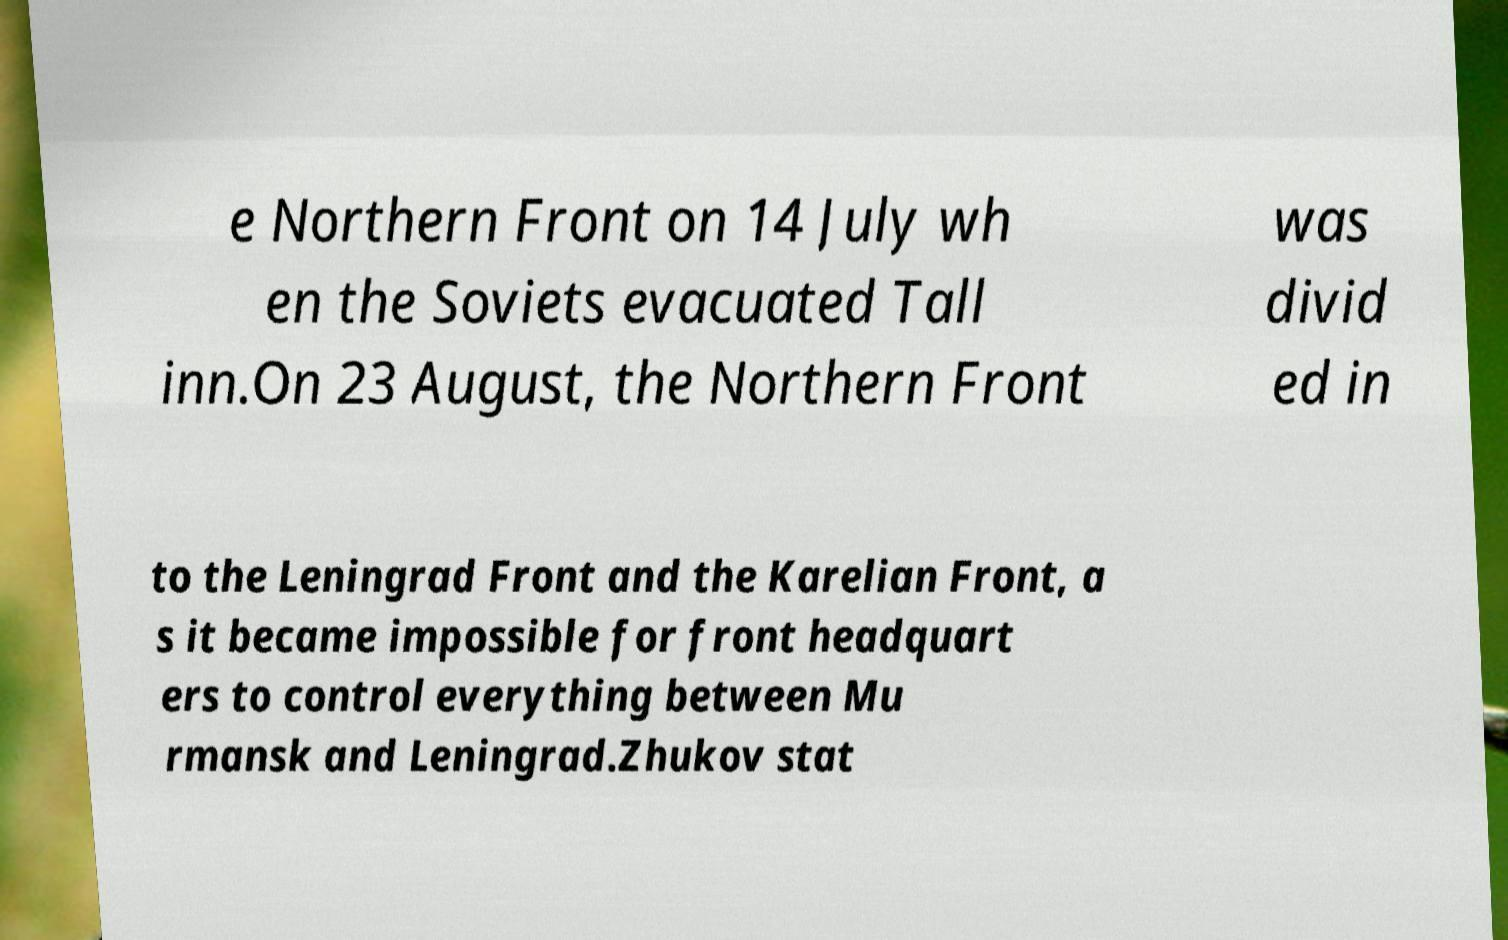Could you assist in decoding the text presented in this image and type it out clearly? e Northern Front on 14 July wh en the Soviets evacuated Tall inn.On 23 August, the Northern Front was divid ed in to the Leningrad Front and the Karelian Front, a s it became impossible for front headquart ers to control everything between Mu rmansk and Leningrad.Zhukov stat 